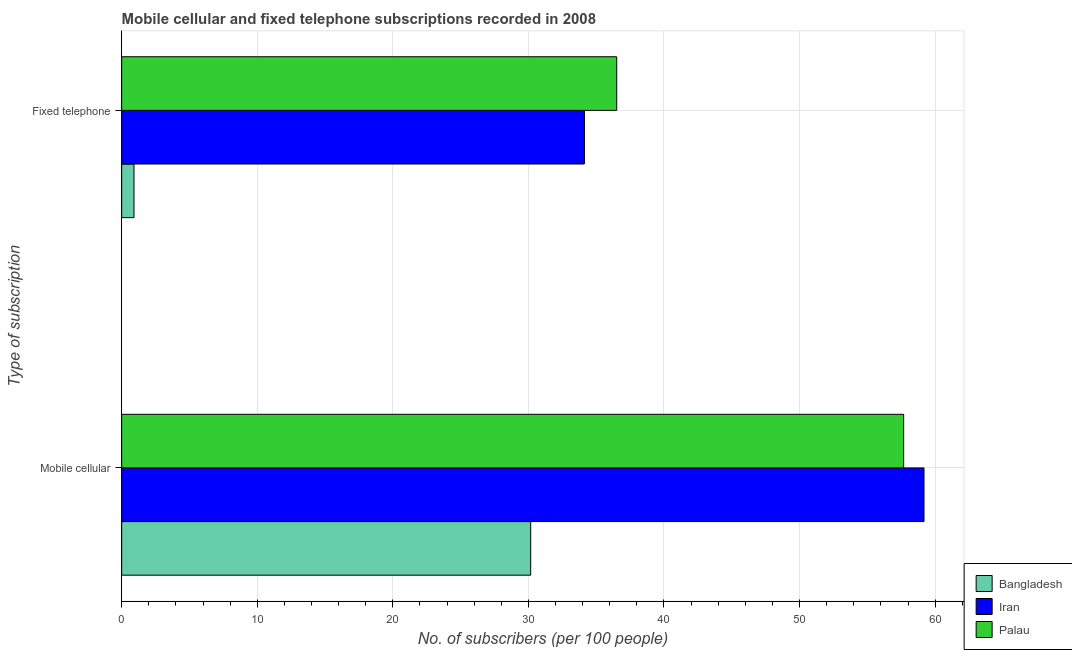How many different coloured bars are there?
Ensure brevity in your answer.  3. Are the number of bars per tick equal to the number of legend labels?
Provide a succinct answer. Yes. Are the number of bars on each tick of the Y-axis equal?
Your answer should be very brief. Yes. What is the label of the 1st group of bars from the top?
Your response must be concise. Fixed telephone. What is the number of fixed telephone subscribers in Iran?
Provide a short and direct response. 34.13. Across all countries, what is the maximum number of mobile cellular subscribers?
Provide a succinct answer. 59.18. Across all countries, what is the minimum number of fixed telephone subscribers?
Make the answer very short. 0.91. In which country was the number of fixed telephone subscribers maximum?
Offer a very short reply. Palau. What is the total number of fixed telephone subscribers in the graph?
Provide a short and direct response. 71.55. What is the difference between the number of fixed telephone subscribers in Palau and that in Bangladesh?
Provide a succinct answer. 35.61. What is the difference between the number of mobile cellular subscribers in Iran and the number of fixed telephone subscribers in Palau?
Provide a succinct answer. 22.67. What is the average number of mobile cellular subscribers per country?
Your answer should be very brief. 49.01. What is the difference between the number of mobile cellular subscribers and number of fixed telephone subscribers in Palau?
Give a very brief answer. 21.16. What is the ratio of the number of fixed telephone subscribers in Bangladesh to that in Iran?
Offer a very short reply. 0.03. Is the number of fixed telephone subscribers in Iran less than that in Bangladesh?
Your response must be concise. No. In how many countries, is the number of mobile cellular subscribers greater than the average number of mobile cellular subscribers taken over all countries?
Provide a succinct answer. 2. What does the 2nd bar from the top in Fixed telephone represents?
Offer a terse response. Iran. What does the 2nd bar from the bottom in Fixed telephone represents?
Offer a very short reply. Iran. How many bars are there?
Your answer should be very brief. 6. Are all the bars in the graph horizontal?
Offer a very short reply. Yes. What is the difference between two consecutive major ticks on the X-axis?
Offer a very short reply. 10. How many legend labels are there?
Your answer should be very brief. 3. What is the title of the graph?
Make the answer very short. Mobile cellular and fixed telephone subscriptions recorded in 2008. What is the label or title of the X-axis?
Make the answer very short. No. of subscribers (per 100 people). What is the label or title of the Y-axis?
Offer a terse response. Type of subscription. What is the No. of subscribers (per 100 people) of Bangladesh in Mobile cellular?
Offer a terse response. 30.17. What is the No. of subscribers (per 100 people) in Iran in Mobile cellular?
Offer a terse response. 59.18. What is the No. of subscribers (per 100 people) in Palau in Mobile cellular?
Offer a very short reply. 57.68. What is the No. of subscribers (per 100 people) in Bangladesh in Fixed telephone?
Ensure brevity in your answer.  0.91. What is the No. of subscribers (per 100 people) of Iran in Fixed telephone?
Ensure brevity in your answer.  34.13. What is the No. of subscribers (per 100 people) of Palau in Fixed telephone?
Offer a terse response. 36.51. Across all Type of subscription, what is the maximum No. of subscribers (per 100 people) in Bangladesh?
Your answer should be very brief. 30.17. Across all Type of subscription, what is the maximum No. of subscribers (per 100 people) in Iran?
Keep it short and to the point. 59.18. Across all Type of subscription, what is the maximum No. of subscribers (per 100 people) in Palau?
Offer a terse response. 57.68. Across all Type of subscription, what is the minimum No. of subscribers (per 100 people) of Bangladesh?
Keep it short and to the point. 0.91. Across all Type of subscription, what is the minimum No. of subscribers (per 100 people) of Iran?
Your answer should be very brief. 34.13. Across all Type of subscription, what is the minimum No. of subscribers (per 100 people) in Palau?
Your answer should be very brief. 36.51. What is the total No. of subscribers (per 100 people) of Bangladesh in the graph?
Provide a succinct answer. 31.08. What is the total No. of subscribers (per 100 people) of Iran in the graph?
Your answer should be compact. 93.31. What is the total No. of subscribers (per 100 people) in Palau in the graph?
Your answer should be very brief. 94.19. What is the difference between the No. of subscribers (per 100 people) of Bangladesh in Mobile cellular and that in Fixed telephone?
Give a very brief answer. 29.26. What is the difference between the No. of subscribers (per 100 people) of Iran in Mobile cellular and that in Fixed telephone?
Make the answer very short. 25.05. What is the difference between the No. of subscribers (per 100 people) of Palau in Mobile cellular and that in Fixed telephone?
Offer a very short reply. 21.16. What is the difference between the No. of subscribers (per 100 people) in Bangladesh in Mobile cellular and the No. of subscribers (per 100 people) in Iran in Fixed telephone?
Offer a very short reply. -3.96. What is the difference between the No. of subscribers (per 100 people) in Bangladesh in Mobile cellular and the No. of subscribers (per 100 people) in Palau in Fixed telephone?
Make the answer very short. -6.35. What is the difference between the No. of subscribers (per 100 people) in Iran in Mobile cellular and the No. of subscribers (per 100 people) in Palau in Fixed telephone?
Your answer should be compact. 22.67. What is the average No. of subscribers (per 100 people) of Bangladesh per Type of subscription?
Your answer should be compact. 15.54. What is the average No. of subscribers (per 100 people) of Iran per Type of subscription?
Make the answer very short. 46.66. What is the average No. of subscribers (per 100 people) in Palau per Type of subscription?
Give a very brief answer. 47.1. What is the difference between the No. of subscribers (per 100 people) of Bangladesh and No. of subscribers (per 100 people) of Iran in Mobile cellular?
Your answer should be compact. -29.01. What is the difference between the No. of subscribers (per 100 people) in Bangladesh and No. of subscribers (per 100 people) in Palau in Mobile cellular?
Ensure brevity in your answer.  -27.51. What is the difference between the No. of subscribers (per 100 people) of Iran and No. of subscribers (per 100 people) of Palau in Mobile cellular?
Provide a short and direct response. 1.5. What is the difference between the No. of subscribers (per 100 people) in Bangladesh and No. of subscribers (per 100 people) in Iran in Fixed telephone?
Give a very brief answer. -33.22. What is the difference between the No. of subscribers (per 100 people) in Bangladesh and No. of subscribers (per 100 people) in Palau in Fixed telephone?
Ensure brevity in your answer.  -35.61. What is the difference between the No. of subscribers (per 100 people) in Iran and No. of subscribers (per 100 people) in Palau in Fixed telephone?
Make the answer very short. -2.38. What is the ratio of the No. of subscribers (per 100 people) of Bangladesh in Mobile cellular to that in Fixed telephone?
Offer a very short reply. 33.2. What is the ratio of the No. of subscribers (per 100 people) in Iran in Mobile cellular to that in Fixed telephone?
Ensure brevity in your answer.  1.73. What is the ratio of the No. of subscribers (per 100 people) of Palau in Mobile cellular to that in Fixed telephone?
Offer a terse response. 1.58. What is the difference between the highest and the second highest No. of subscribers (per 100 people) in Bangladesh?
Offer a terse response. 29.26. What is the difference between the highest and the second highest No. of subscribers (per 100 people) of Iran?
Provide a succinct answer. 25.05. What is the difference between the highest and the second highest No. of subscribers (per 100 people) in Palau?
Make the answer very short. 21.16. What is the difference between the highest and the lowest No. of subscribers (per 100 people) in Bangladesh?
Your answer should be very brief. 29.26. What is the difference between the highest and the lowest No. of subscribers (per 100 people) in Iran?
Give a very brief answer. 25.05. What is the difference between the highest and the lowest No. of subscribers (per 100 people) in Palau?
Ensure brevity in your answer.  21.16. 